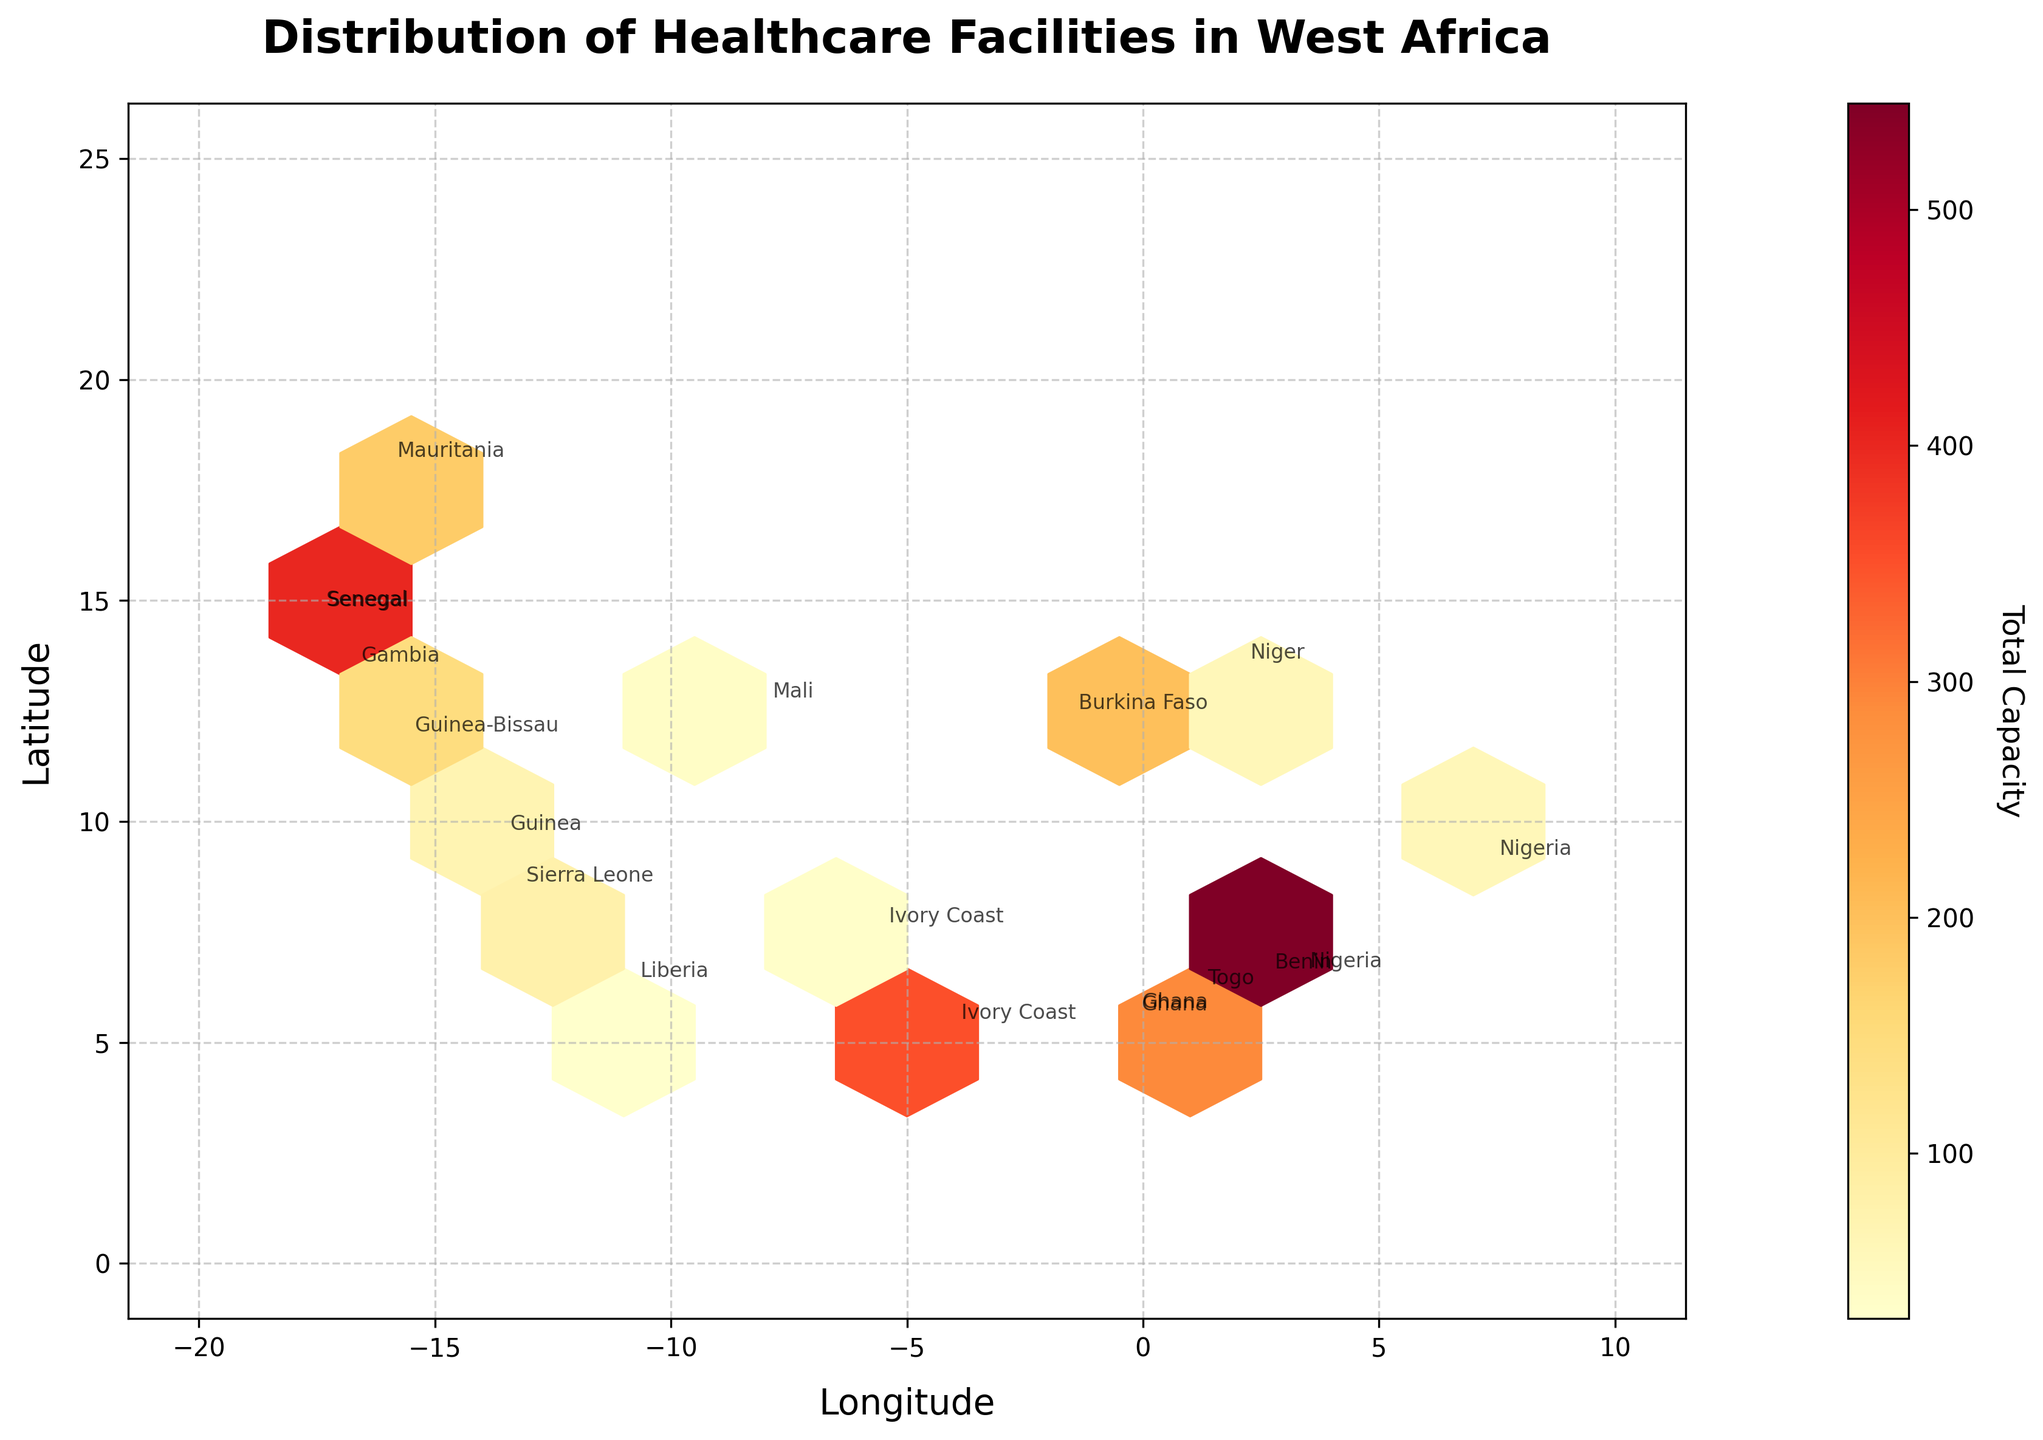What is the title of the plot? The title is prominently displayed at the top of the plot. It helps to immediately understand the context.
Answer: Distribution of Healthcare Facilities in West Africa What are the ranges of latitude and longitude represented in the plot? The latitude ranges from 0 to 25 degrees and the longitude ranges from -20 to 10 degrees. These are outlined along the axes of the plot.
Answer: Latitude: 0 to 25, Longitude: -20 to 10 Which country has the highest concentration of healthcare facilities? Based on the density of the hexagons and the annotation, Nigeria shows the highest concentration in its region.
Answer: Nigeria What does the color of the hexagons represent in the plot? The color gradient from yellow to red indicates the total capacity of healthcare facilities in that area; the redder the hexagon, the higher the total capacity.
Answer: Total capacity How does the total capacity in Nigeria compare to that in Ghana? By comparing the hexagon colors and annotations, Nigeria has more densely packed red areas indicating a higher total capacity than Ghana.
Answer: Nigeria has a higher total capacity Which country has a higher capacity: Liberia or Guinea-Bissau? By observing the hexagon colors and annotations, Liberia's area has more yellow (indicating higher capacity) compared to Guinea-Bissau.
Answer: Liberia What type of healthcare facilities are most common in regions near the equator? By looking at the annotations for countries near the equator (e.g., Nigeria, Ghana, Ivory Coast, and Togo), the types include Hospitals, Clinics, and Health Centers.
Answer: Hospitals and Clinics Are there more hospitals or clinics in the entire dataset? From the annotations, count the occurrences of "Hospital" and "Clinic" across the countries. There are more hospitals visible in the areas tagged.
Answer: More hospitals What color indicates the highest total capacity in the plot? The color bar to the right of the plot shows a gradient, with red indicating the highest total capacity.
Answer: Red Which country has the lowest healthcare facility capacity according to the hexbin plot? Look for the country with the lighter color hexagons among the annotations, which indicates lower capacity, such as Guinea-Bissau.
Answer: Guinea-Bissau 